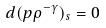Convert formula to latex. <formula><loc_0><loc_0><loc_500><loc_500>d ( p \rho ^ { - \gamma } ) _ { s } = 0</formula> 